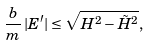Convert formula to latex. <formula><loc_0><loc_0><loc_500><loc_500>\frac { b } { m } \, | E ^ { \prime } | \leq \sqrt { H ^ { 2 } - \tilde { H } ^ { 2 } } ,</formula> 